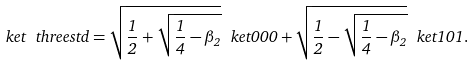<formula> <loc_0><loc_0><loc_500><loc_500>\ k e t { \ t h r e e s t d } = \sqrt { \frac { 1 } { 2 } + \sqrt { \frac { 1 } { 4 } - \beta _ { 2 } } } \ k e t { 0 0 0 } + \sqrt { \frac { 1 } { 2 } - \sqrt { \frac { 1 } { 4 } - \beta _ { 2 } } } \ k e t { 1 0 1 } .</formula> 